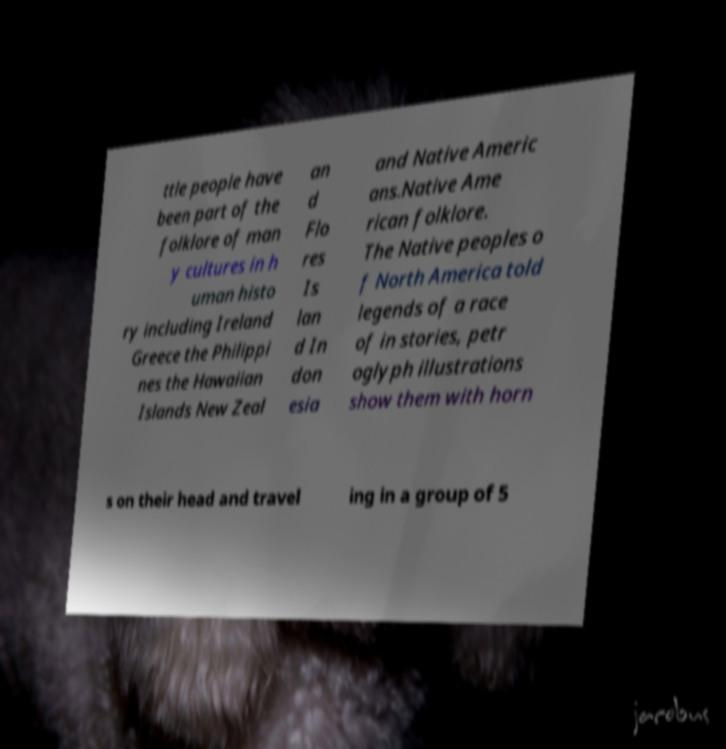Could you extract and type out the text from this image? ttle people have been part of the folklore of man y cultures in h uman histo ry including Ireland Greece the Philippi nes the Hawaiian Islands New Zeal an d Flo res Is lan d In don esia and Native Americ ans.Native Ame rican folklore. The Native peoples o f North America told legends of a race of in stories, petr oglyph illustrations show them with horn s on their head and travel ing in a group of 5 